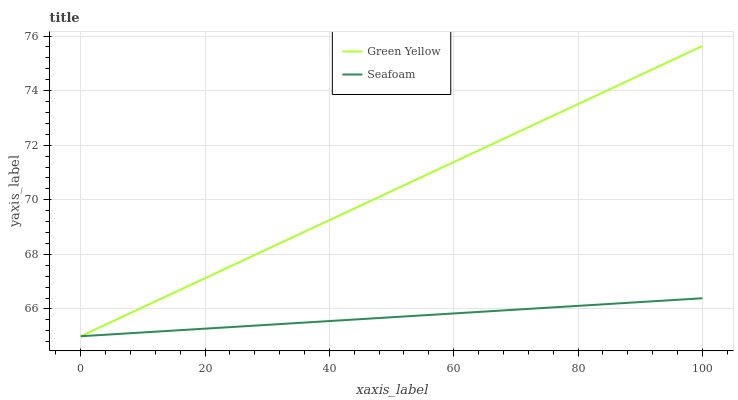Does Seafoam have the minimum area under the curve?
Answer yes or no. Yes. Does Green Yellow have the maximum area under the curve?
Answer yes or no. Yes. Does Seafoam have the maximum area under the curve?
Answer yes or no. No. Is Green Yellow the smoothest?
Answer yes or no. Yes. Is Seafoam the roughest?
Answer yes or no. Yes. Is Seafoam the smoothest?
Answer yes or no. No. Does Green Yellow have the lowest value?
Answer yes or no. Yes. Does Green Yellow have the highest value?
Answer yes or no. Yes. Does Seafoam have the highest value?
Answer yes or no. No. Does Green Yellow intersect Seafoam?
Answer yes or no. Yes. Is Green Yellow less than Seafoam?
Answer yes or no. No. Is Green Yellow greater than Seafoam?
Answer yes or no. No. 